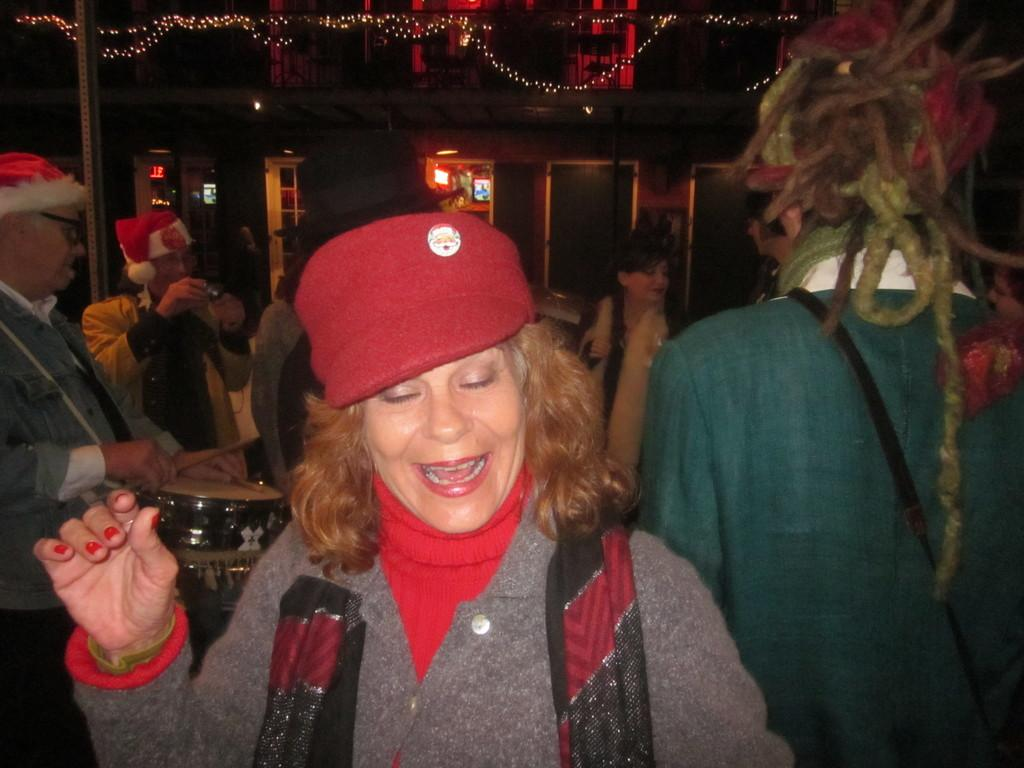What is the main subject of the image? The main subject of the image is a group of people. Can you describe any specific clothing or accessories worn by the people in the image? Some people in the group are wearing caps. Where is the man located in the image? The man is on the left side of the image. What is the man doing in the image? The man is playing a drum. What can be seen in the background of the image? There are lights visible in the background of the image. What type of corn is being harvested in the image? There is no corn present in the image; it features a group of people, some of whom are wearing caps, and a man playing a drum. How many people are sleeping in the image? There are no people sleeping in the image; all the people are engaged in various activities. 